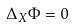<formula> <loc_0><loc_0><loc_500><loc_500>\Delta _ { X } \Phi = 0</formula> 